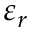<formula> <loc_0><loc_0><loc_500><loc_500>\varepsilon _ { r }</formula> 